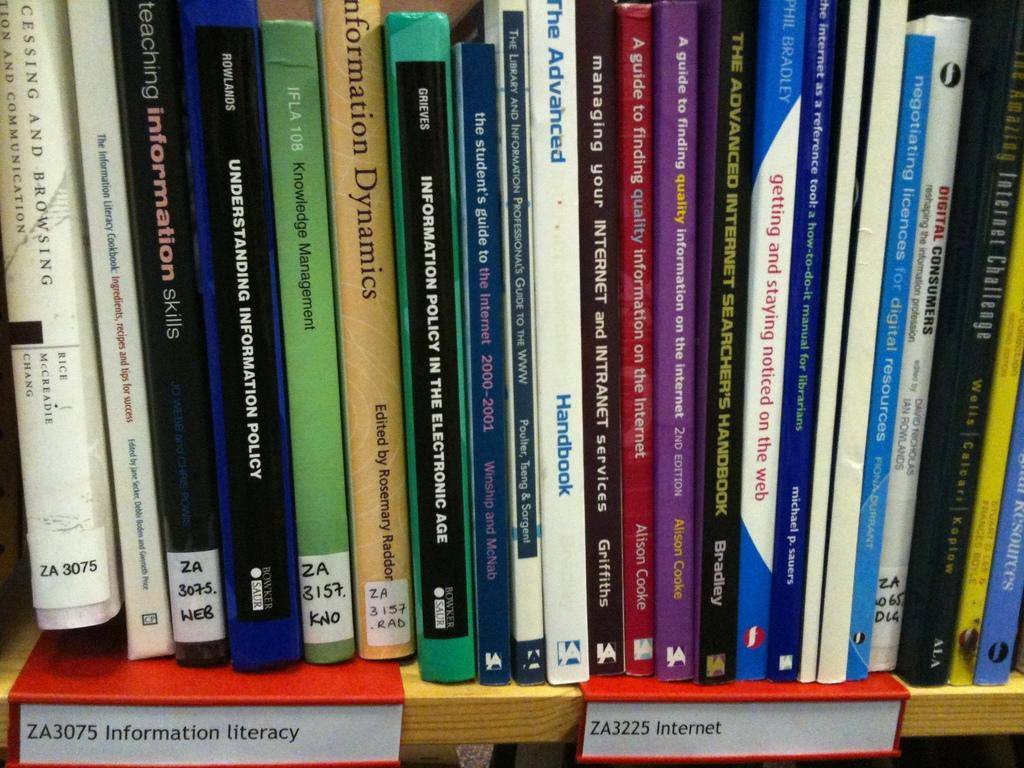<image>
Share a concise interpretation of the image provided. a book has the word browsing on the side 